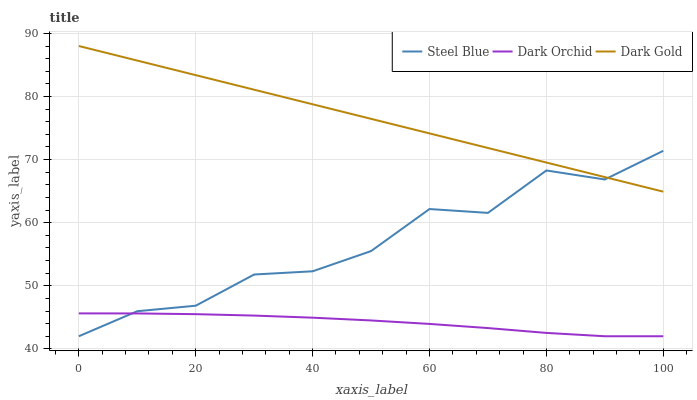Does Dark Orchid have the minimum area under the curve?
Answer yes or no. Yes. Does Dark Gold have the maximum area under the curve?
Answer yes or no. Yes. Does Dark Gold have the minimum area under the curve?
Answer yes or no. No. Does Dark Orchid have the maximum area under the curve?
Answer yes or no. No. Is Dark Gold the smoothest?
Answer yes or no. Yes. Is Steel Blue the roughest?
Answer yes or no. Yes. Is Dark Orchid the smoothest?
Answer yes or no. No. Is Dark Orchid the roughest?
Answer yes or no. No. Does Steel Blue have the lowest value?
Answer yes or no. Yes. Does Dark Gold have the lowest value?
Answer yes or no. No. Does Dark Gold have the highest value?
Answer yes or no. Yes. Does Dark Orchid have the highest value?
Answer yes or no. No. Is Dark Orchid less than Dark Gold?
Answer yes or no. Yes. Is Dark Gold greater than Dark Orchid?
Answer yes or no. Yes. Does Steel Blue intersect Dark Orchid?
Answer yes or no. Yes. Is Steel Blue less than Dark Orchid?
Answer yes or no. No. Is Steel Blue greater than Dark Orchid?
Answer yes or no. No. Does Dark Orchid intersect Dark Gold?
Answer yes or no. No. 